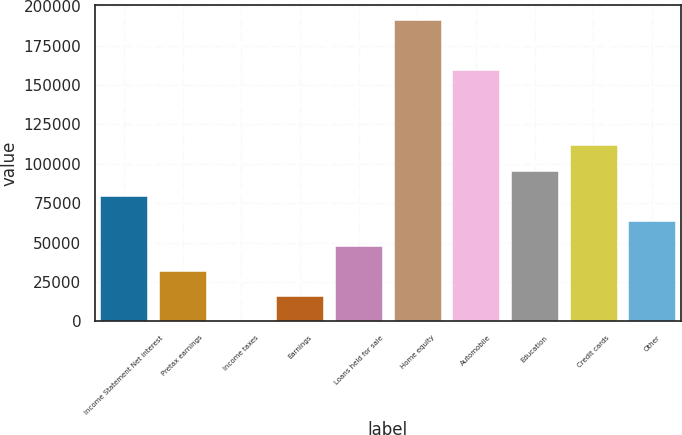Convert chart. <chart><loc_0><loc_0><loc_500><loc_500><bar_chart><fcel>Income Statement Net interest<fcel>Pretax earnings<fcel>Income taxes<fcel>Earnings<fcel>Loans held for sale<fcel>Home equity<fcel>Automobile<fcel>Education<fcel>Credit cards<fcel>Other<nl><fcel>79798.5<fcel>32112.6<fcel>322<fcel>16217.3<fcel>48007.9<fcel>191066<fcel>159275<fcel>95693.8<fcel>111589<fcel>63903.2<nl></chart> 